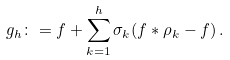Convert formula to latex. <formula><loc_0><loc_0><loc_500><loc_500>g _ { h } \colon = f + \sum _ { k = 1 } ^ { h } \sigma _ { k } ( f * \rho _ { k } - f ) \, .</formula> 